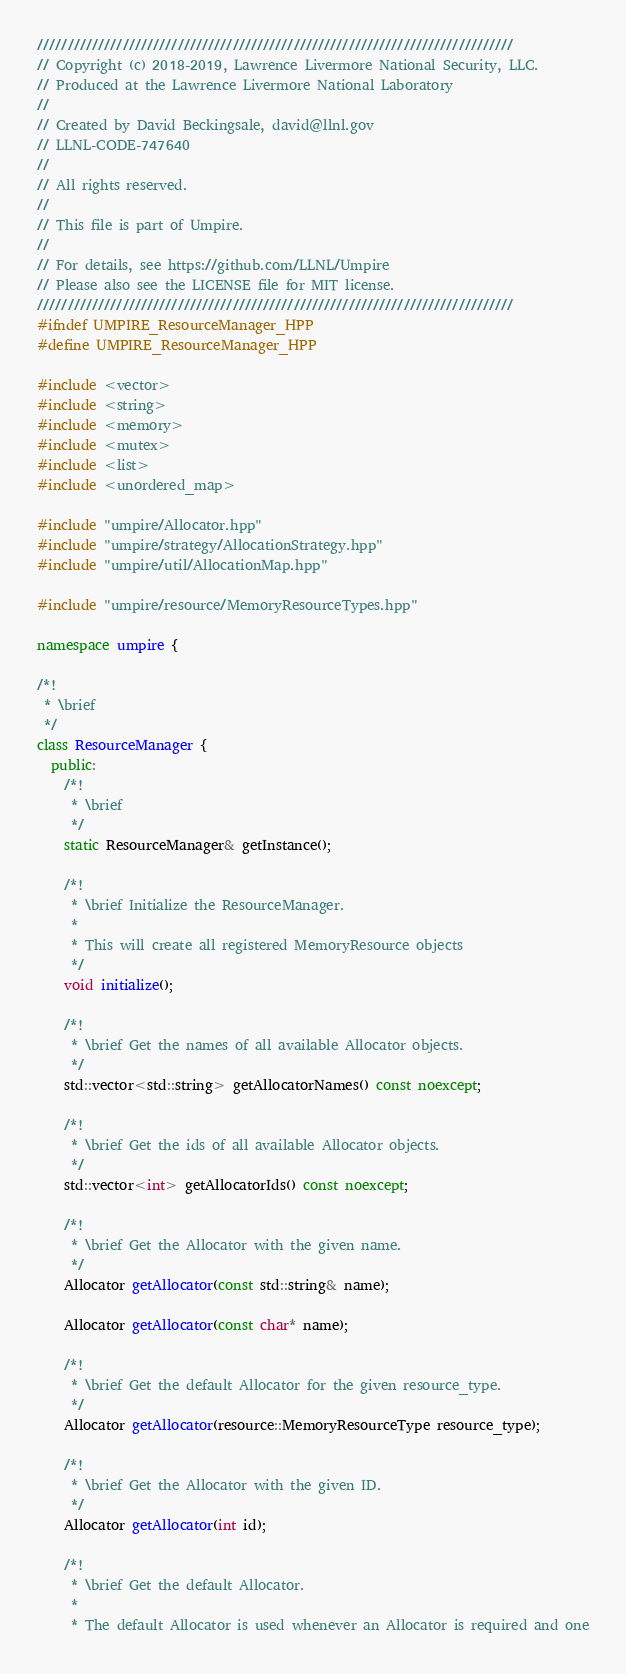Convert code to text. <code><loc_0><loc_0><loc_500><loc_500><_C++_>//////////////////////////////////////////////////////////////////////////////
// Copyright (c) 2018-2019, Lawrence Livermore National Security, LLC.
// Produced at the Lawrence Livermore National Laboratory
//
// Created by David Beckingsale, david@llnl.gov
// LLNL-CODE-747640
//
// All rights reserved.
//
// This file is part of Umpire.
//
// For details, see https://github.com/LLNL/Umpire
// Please also see the LICENSE file for MIT license.
//////////////////////////////////////////////////////////////////////////////
#ifndef UMPIRE_ResourceManager_HPP
#define UMPIRE_ResourceManager_HPP

#include <vector>
#include <string>
#include <memory>
#include <mutex>
#include <list>
#include <unordered_map>

#include "umpire/Allocator.hpp"
#include "umpire/strategy/AllocationStrategy.hpp"
#include "umpire/util/AllocationMap.hpp"

#include "umpire/resource/MemoryResourceTypes.hpp"

namespace umpire {

/*!
 * \brief
 */
class ResourceManager {
  public:
    /*!
     * \brief
     */
    static ResourceManager& getInstance();

    /*!
     * \brief Initialize the ResourceManager.
     *
     * This will create all registered MemoryResource objects
     */
    void initialize();

    /*!
     * \brief Get the names of all available Allocator objects.
     */
    std::vector<std::string> getAllocatorNames() const noexcept;

    /*!
     * \brief Get the ids of all available Allocator objects.
     */
    std::vector<int> getAllocatorIds() const noexcept;

    /*!
     * \brief Get the Allocator with the given name.
     */
    Allocator getAllocator(const std::string& name);

    Allocator getAllocator(const char* name);

    /*!
     * \brief Get the default Allocator for the given resource_type.
     */
    Allocator getAllocator(resource::MemoryResourceType resource_type);

    /*!
     * \brief Get the Allocator with the given ID.
     */
    Allocator getAllocator(int id);

    /*!
     * \brief Get the default Allocator.
     *
     * The default Allocator is used whenever an Allocator is required and one</code> 